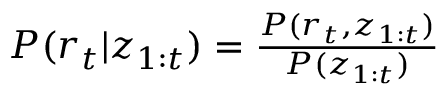Convert formula to latex. <formula><loc_0><loc_0><loc_500><loc_500>\begin{array} { r } { P ( r _ { t } | z _ { 1 \colon t } ) = \frac { P ( r _ { t } , z _ { 1 \colon t } ) } { P ( z _ { 1 \colon t } ) } } \end{array}</formula> 